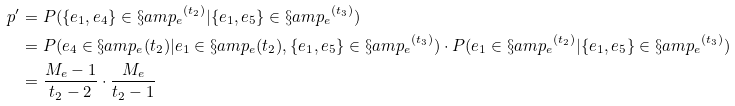<formula> <loc_0><loc_0><loc_500><loc_500>p ^ { \prime } & = P ( \{ e _ { 1 } , e _ { 4 } \} \in { \S a m p _ { e } } ^ { ( t _ { 2 } ) } | \{ e _ { 1 } , e _ { 5 } \} \in { \S a m p _ { e } } ^ { ( t _ { 3 } ) } ) \\ & = P ( e _ { 4 } \in \S a m p _ { e } ( t _ { 2 } ) | e _ { 1 } \in \S a m p _ { e } ( t _ { 2 } ) , \{ e _ { 1 } , e _ { 5 } \} \in { \S a m p _ { e } } ^ { ( t _ { 3 } ) } ) \cdot P ( e _ { 1 } \in { \S a m p _ { e } } ^ { ( t _ { 2 } ) } | \{ e _ { 1 } , e _ { 5 } \} \in { \S a m p _ { e } } ^ { ( t _ { 3 } ) } ) \\ & = \frac { M _ { e } - 1 } { t _ { 2 } - 2 } \cdot \frac { M _ { e } } { t _ { 2 } - 1 }</formula> 